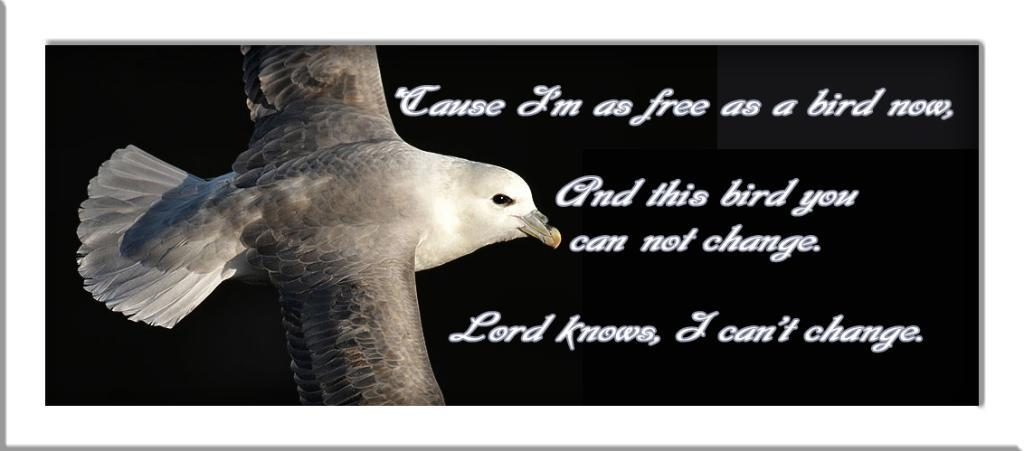What is featured on the poster in the image? There is a poster in the image, and it has a bird on it. What else can be seen on the poster besides the bird? There is text on the poster. How many feet are visible on the poster? There are no feet visible on the poster; it features a bird and text. What type of street is shown in the background of the poster? There is no street shown in the image, as the focus is on the poster itself. 